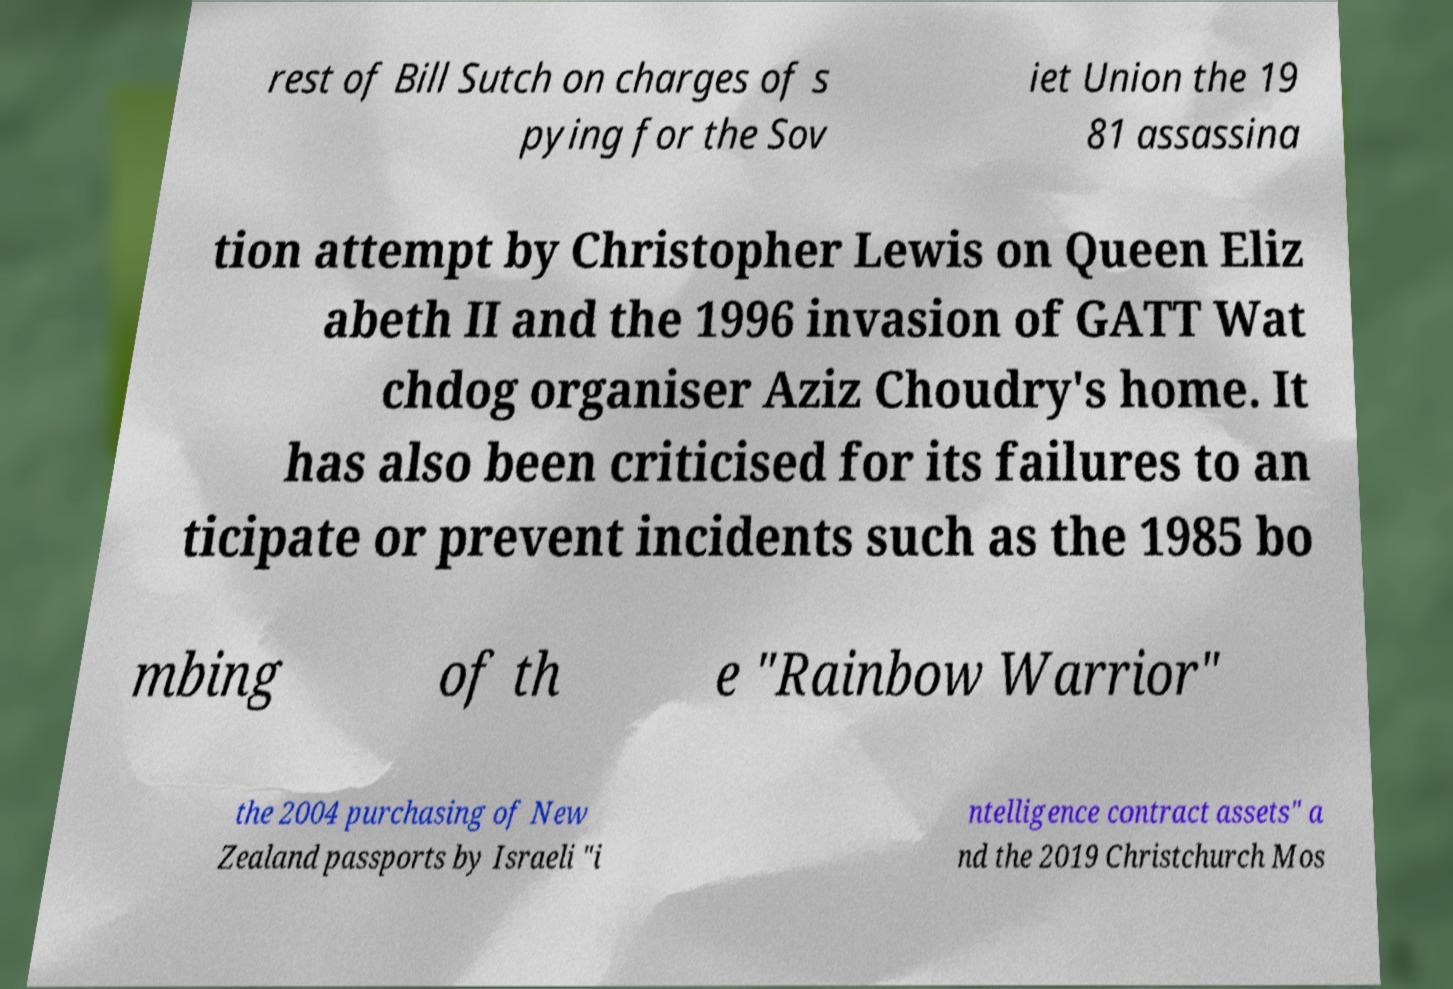Could you extract and type out the text from this image? rest of Bill Sutch on charges of s pying for the Sov iet Union the 19 81 assassina tion attempt by Christopher Lewis on Queen Eliz abeth II and the 1996 invasion of GATT Wat chdog organiser Aziz Choudry's home. It has also been criticised for its failures to an ticipate or prevent incidents such as the 1985 bo mbing of th e "Rainbow Warrior" the 2004 purchasing of New Zealand passports by Israeli "i ntelligence contract assets" a nd the 2019 Christchurch Mos 